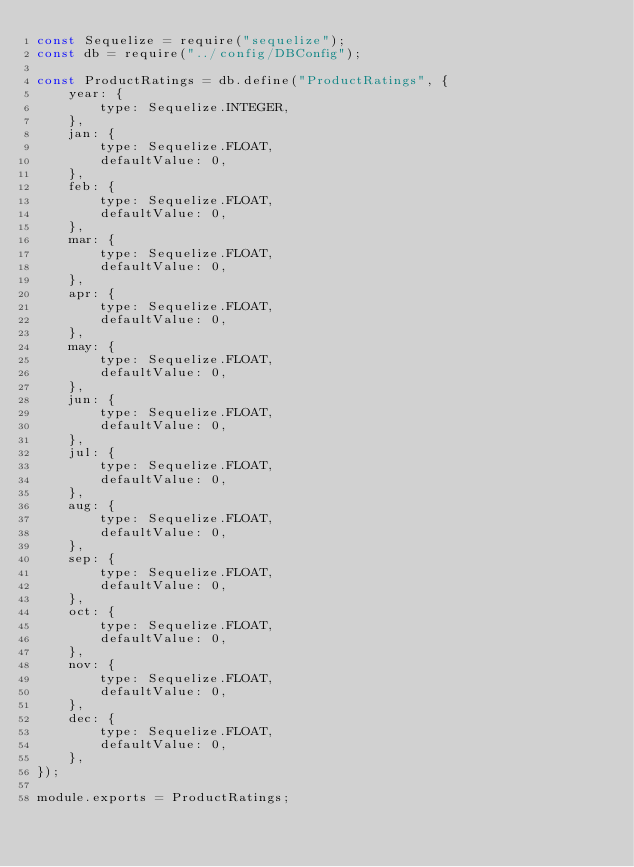<code> <loc_0><loc_0><loc_500><loc_500><_JavaScript_>const Sequelize = require("sequelize");
const db = require("../config/DBConfig");

const ProductRatings = db.define("ProductRatings", {
	year: {
		type: Sequelize.INTEGER,
	},
    jan: {
        type: Sequelize.FLOAT,
        defaultValue: 0,
    },
    feb: {
        type: Sequelize.FLOAT,
        defaultValue: 0,
    },
    mar: {
        type: Sequelize.FLOAT,
        defaultValue: 0,
    },
    apr: {
        type: Sequelize.FLOAT,
        defaultValue: 0,
    },
    may: {
        type: Sequelize.FLOAT,
        defaultValue: 0,
    },
    jun: {
        type: Sequelize.FLOAT,
        defaultValue: 0,
    },
    jul: {
        type: Sequelize.FLOAT,
        defaultValue: 0,
    },
    aug: {
        type: Sequelize.FLOAT,
        defaultValue: 0,
    },
    sep: {
        type: Sequelize.FLOAT,
        defaultValue: 0,
    },
    oct: {
        type: Sequelize.FLOAT,
        defaultValue: 0,
    },
    nov: {
        type: Sequelize.FLOAT,
        defaultValue: 0,
    },
    dec: {
        type: Sequelize.FLOAT,
        defaultValue: 0,
    },
});

module.exports = ProductRatings;
</code> 